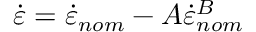Convert formula to latex. <formula><loc_0><loc_0><loc_500><loc_500>\dot { \varepsilon } = \dot { \varepsilon } _ { n o m } - A { \dot { \varepsilon } _ { n o m } } ^ { B }</formula> 